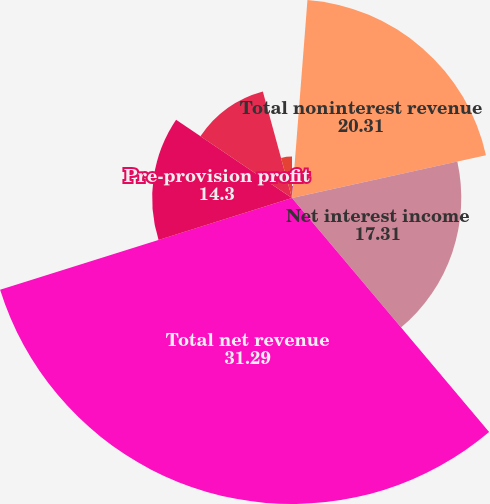<chart> <loc_0><loc_0><loc_500><loc_500><pie_chart><fcel>Other income<fcel>Total noninterest revenue<fcel>Net interest income<fcel>Total net revenue<fcel>Pre-provision profit<fcel>Income before income tax<fcel>Income tax expense<nl><fcel>1.24%<fcel>20.31%<fcel>17.31%<fcel>31.29%<fcel>14.3%<fcel>11.3%<fcel>4.25%<nl></chart> 